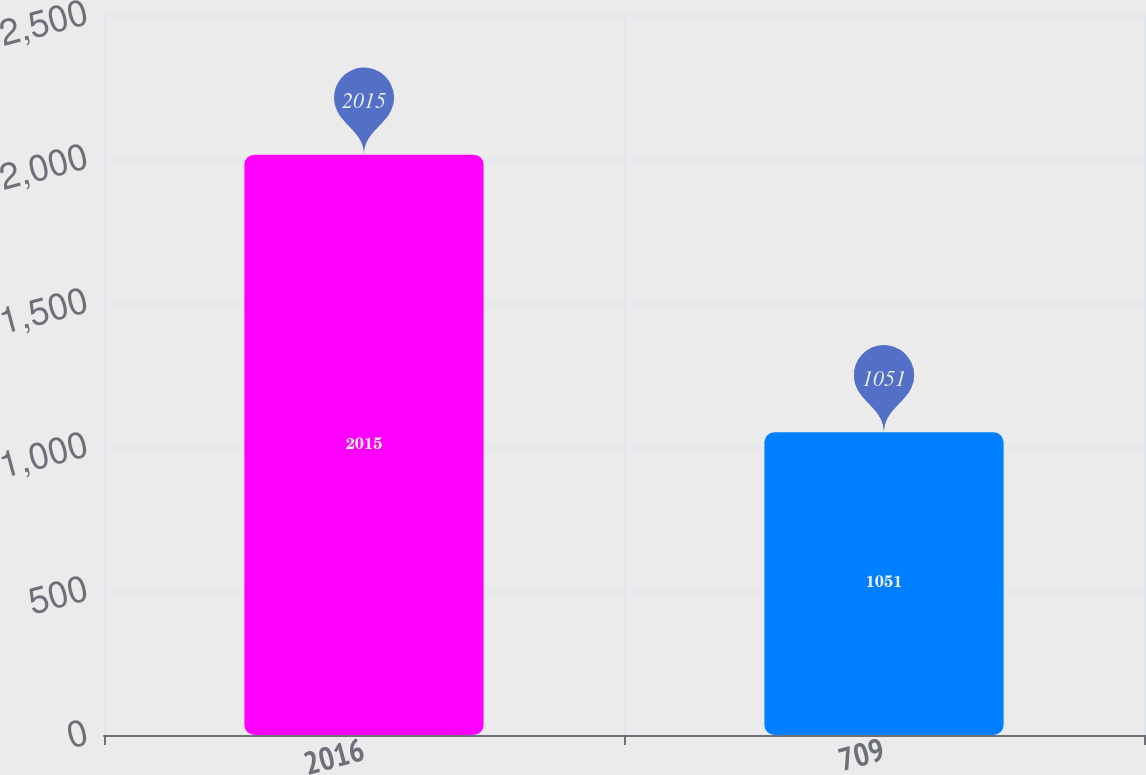Convert chart. <chart><loc_0><loc_0><loc_500><loc_500><bar_chart><fcel>2016<fcel>709<nl><fcel>2015<fcel>1051<nl></chart> 